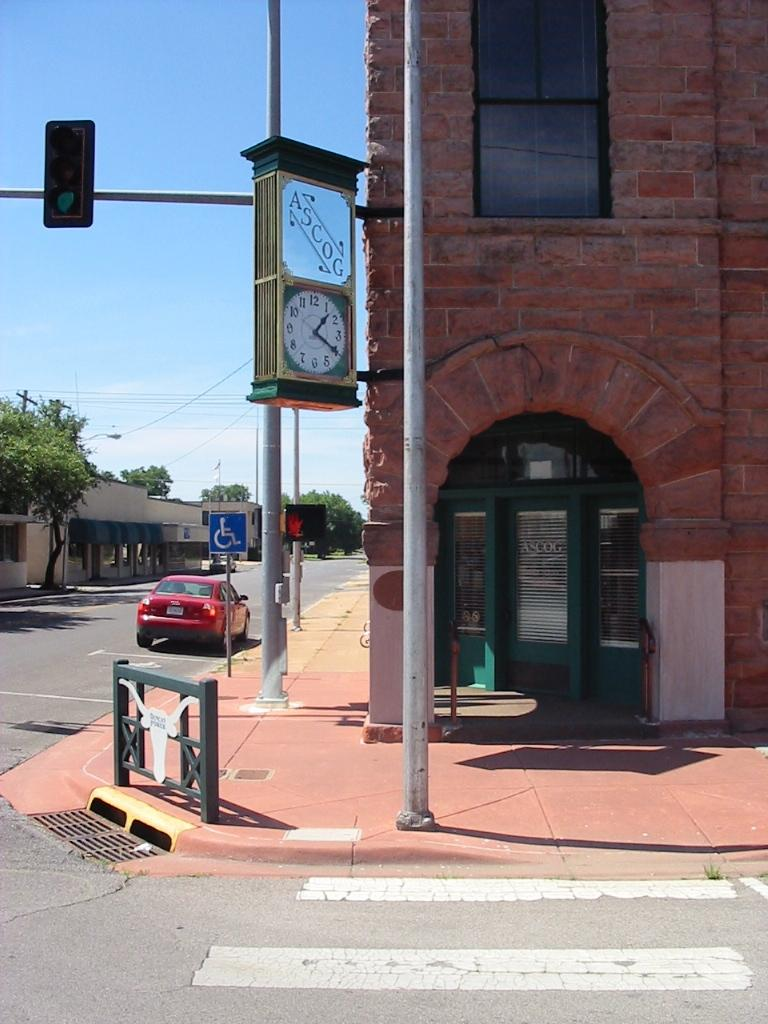<image>
Render a clear and concise summary of the photo. A clock is hanging outside a corner store, underneath a sign that says ASCOG. 